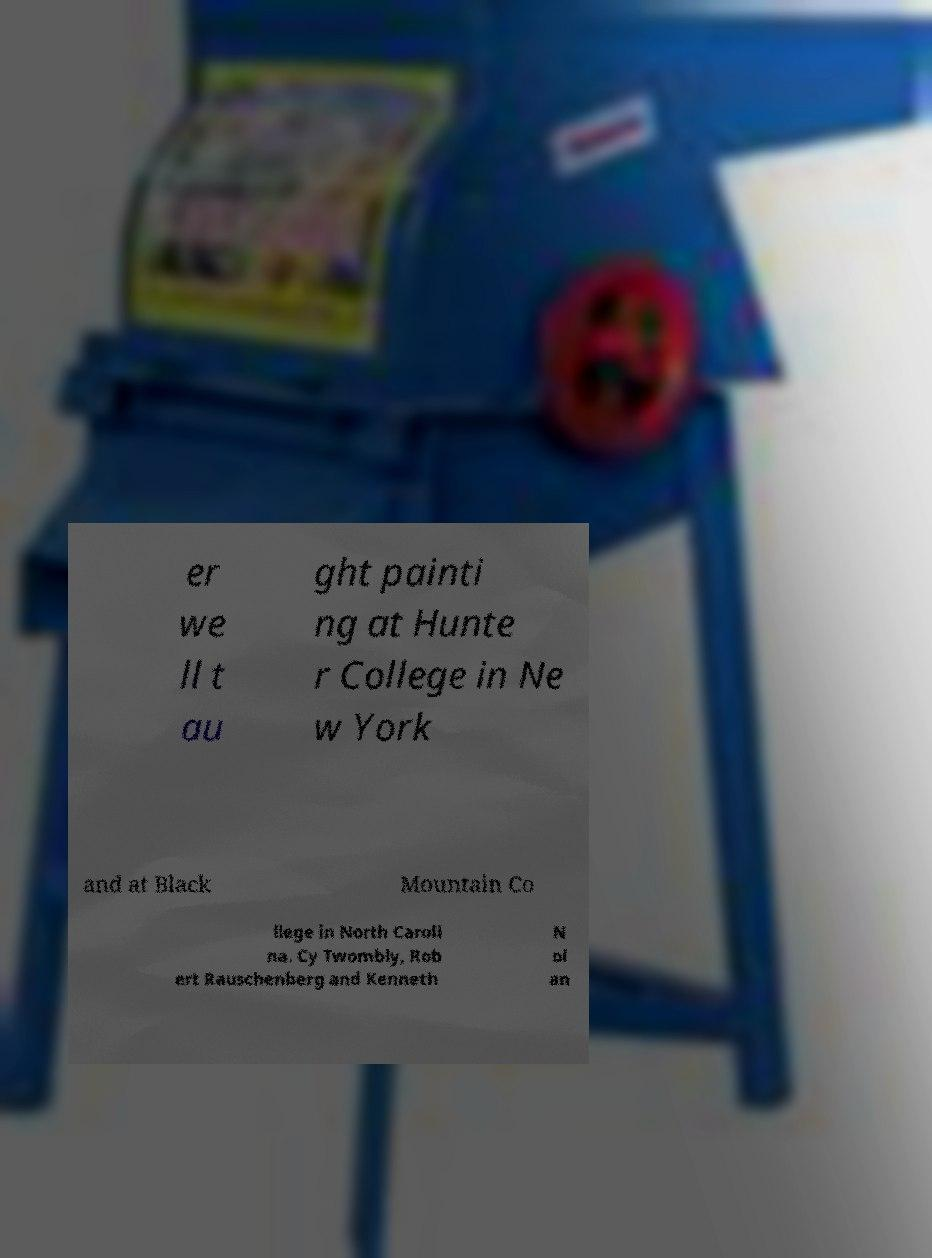Could you extract and type out the text from this image? er we ll t au ght painti ng at Hunte r College in Ne w York and at Black Mountain Co llege in North Caroli na. Cy Twombly, Rob ert Rauschenberg and Kenneth N ol an 